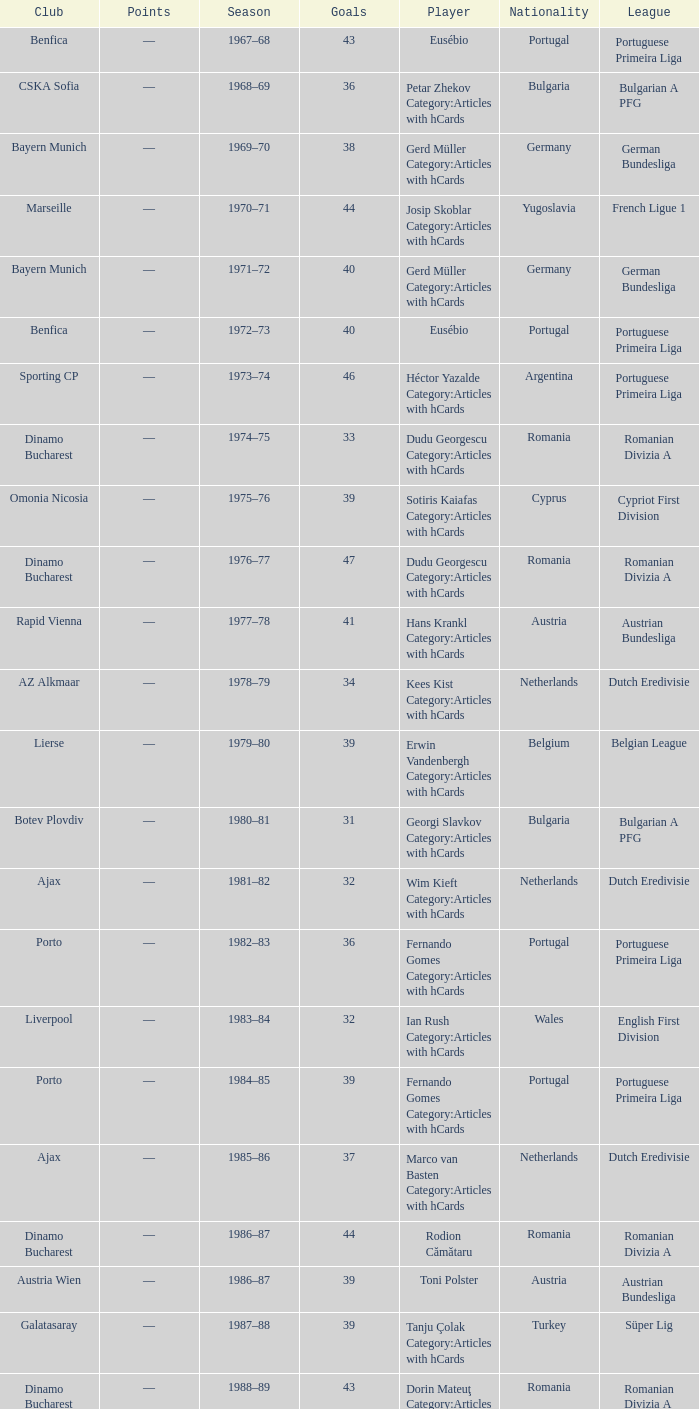Which league's nationality was Italy when there were 62 points? Italian Serie A. 